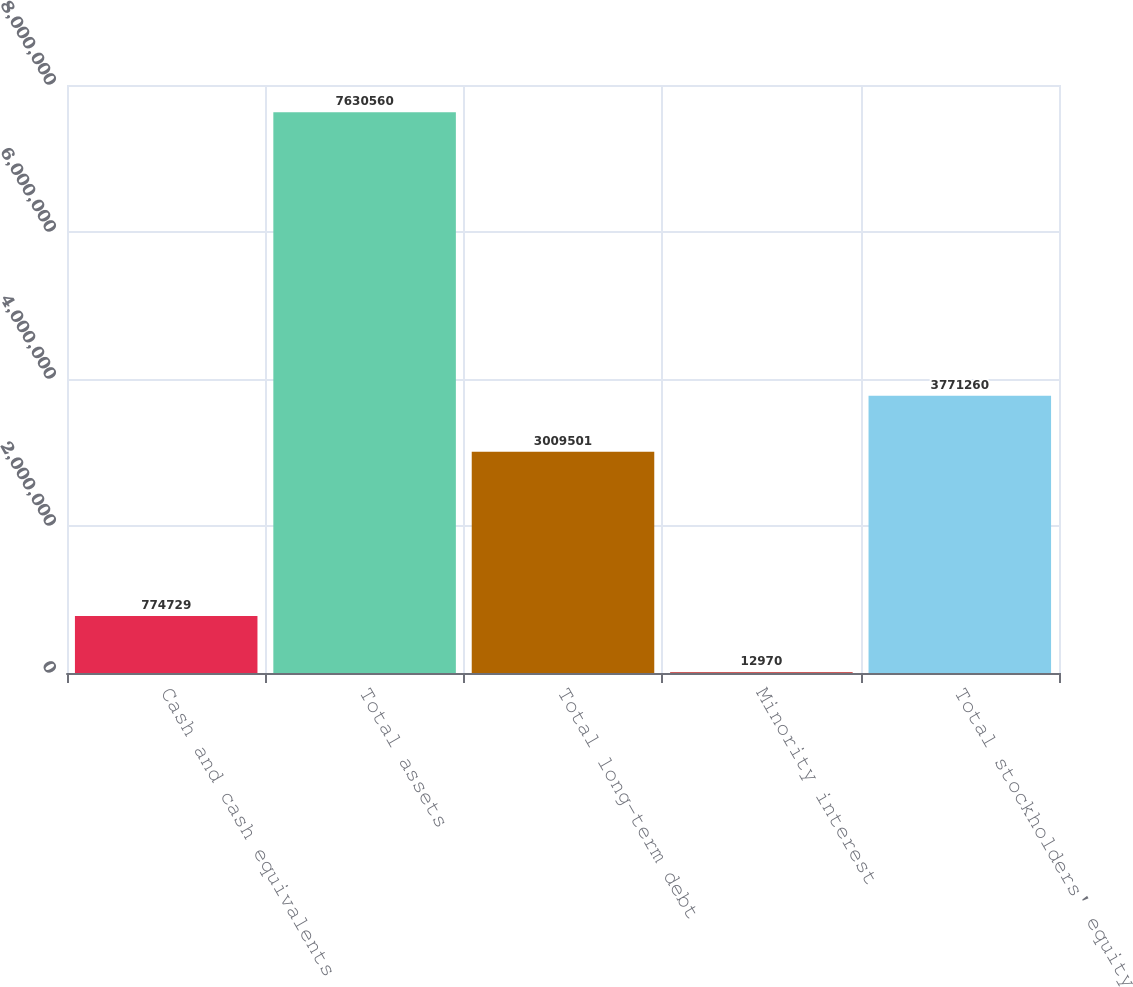Convert chart. <chart><loc_0><loc_0><loc_500><loc_500><bar_chart><fcel>Cash and cash equivalents<fcel>Total assets<fcel>Total long-term debt<fcel>Minority interest<fcel>Total stockholders' equity<nl><fcel>774729<fcel>7.63056e+06<fcel>3.0095e+06<fcel>12970<fcel>3.77126e+06<nl></chart> 